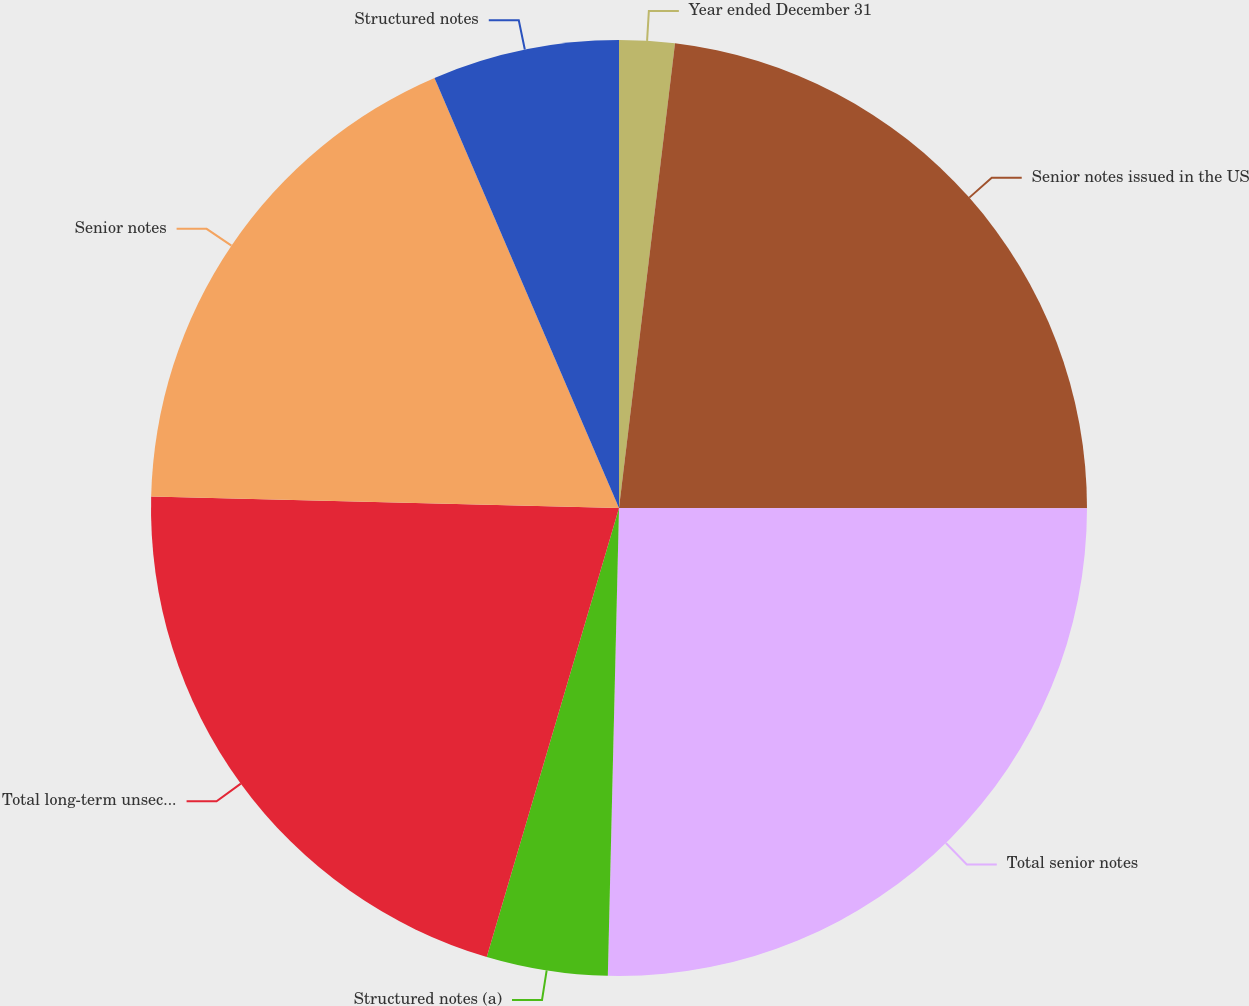<chart> <loc_0><loc_0><loc_500><loc_500><pie_chart><fcel>Year ended December 31<fcel>Senior notes issued in the US<fcel>Total senior notes<fcel>Structured notes (a)<fcel>Total long-term unsecured<fcel>Senior notes<fcel>Structured notes<nl><fcel>1.91%<fcel>23.1%<fcel>25.37%<fcel>4.18%<fcel>20.83%<fcel>18.16%<fcel>6.45%<nl></chart> 